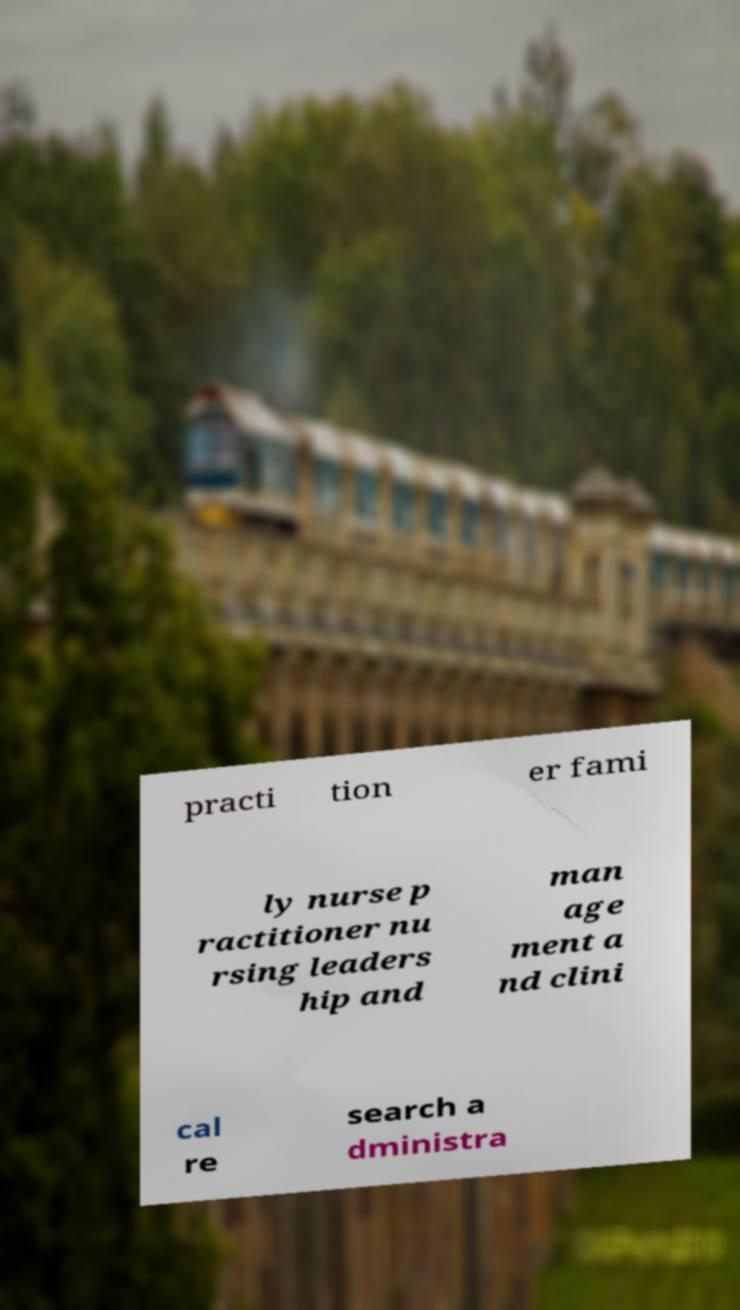Please read and relay the text visible in this image. What does it say? practi tion er fami ly nurse p ractitioner nu rsing leaders hip and man age ment a nd clini cal re search a dministra 